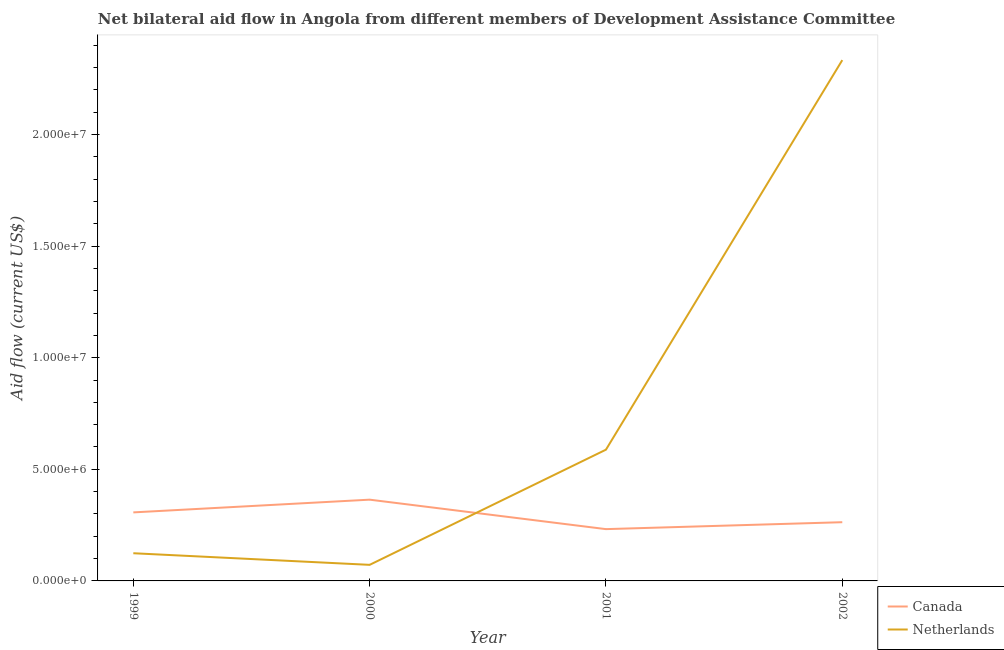How many different coloured lines are there?
Keep it short and to the point. 2. Does the line corresponding to amount of aid given by canada intersect with the line corresponding to amount of aid given by netherlands?
Make the answer very short. Yes. What is the amount of aid given by netherlands in 2000?
Provide a short and direct response. 7.20e+05. Across all years, what is the maximum amount of aid given by netherlands?
Offer a terse response. 2.33e+07. Across all years, what is the minimum amount of aid given by canada?
Provide a short and direct response. 2.32e+06. In which year was the amount of aid given by netherlands minimum?
Ensure brevity in your answer.  2000. What is the total amount of aid given by canada in the graph?
Your answer should be compact. 1.17e+07. What is the difference between the amount of aid given by netherlands in 1999 and that in 2002?
Keep it short and to the point. -2.21e+07. What is the difference between the amount of aid given by netherlands in 2002 and the amount of aid given by canada in 2001?
Keep it short and to the point. 2.10e+07. What is the average amount of aid given by canada per year?
Your response must be concise. 2.92e+06. In the year 2001, what is the difference between the amount of aid given by netherlands and amount of aid given by canada?
Give a very brief answer. 3.56e+06. In how many years, is the amount of aid given by netherlands greater than 5000000 US$?
Offer a very short reply. 2. What is the ratio of the amount of aid given by canada in 2000 to that in 2002?
Make the answer very short. 1.38. Is the difference between the amount of aid given by netherlands in 1999 and 2000 greater than the difference between the amount of aid given by canada in 1999 and 2000?
Your answer should be very brief. Yes. What is the difference between the highest and the second highest amount of aid given by netherlands?
Provide a short and direct response. 1.74e+07. What is the difference between the highest and the lowest amount of aid given by netherlands?
Your answer should be very brief. 2.26e+07. In how many years, is the amount of aid given by netherlands greater than the average amount of aid given by netherlands taken over all years?
Your answer should be very brief. 1. Is the sum of the amount of aid given by netherlands in 2000 and 2002 greater than the maximum amount of aid given by canada across all years?
Offer a terse response. Yes. Is the amount of aid given by canada strictly greater than the amount of aid given by netherlands over the years?
Provide a short and direct response. No. Is the amount of aid given by netherlands strictly less than the amount of aid given by canada over the years?
Your answer should be very brief. No. How many years are there in the graph?
Keep it short and to the point. 4. Are the values on the major ticks of Y-axis written in scientific E-notation?
Make the answer very short. Yes. Does the graph contain any zero values?
Your answer should be very brief. No. Does the graph contain grids?
Your answer should be compact. No. Where does the legend appear in the graph?
Provide a succinct answer. Bottom right. How are the legend labels stacked?
Keep it short and to the point. Vertical. What is the title of the graph?
Make the answer very short. Net bilateral aid flow in Angola from different members of Development Assistance Committee. Does "ODA received" appear as one of the legend labels in the graph?
Provide a short and direct response. No. What is the label or title of the X-axis?
Provide a succinct answer. Year. What is the label or title of the Y-axis?
Offer a very short reply. Aid flow (current US$). What is the Aid flow (current US$) in Canada in 1999?
Provide a short and direct response. 3.07e+06. What is the Aid flow (current US$) of Netherlands in 1999?
Offer a terse response. 1.24e+06. What is the Aid flow (current US$) in Canada in 2000?
Provide a short and direct response. 3.64e+06. What is the Aid flow (current US$) in Netherlands in 2000?
Your answer should be very brief. 7.20e+05. What is the Aid flow (current US$) in Canada in 2001?
Give a very brief answer. 2.32e+06. What is the Aid flow (current US$) of Netherlands in 2001?
Provide a short and direct response. 5.88e+06. What is the Aid flow (current US$) in Canada in 2002?
Your answer should be compact. 2.63e+06. What is the Aid flow (current US$) in Netherlands in 2002?
Offer a terse response. 2.33e+07. Across all years, what is the maximum Aid flow (current US$) of Canada?
Give a very brief answer. 3.64e+06. Across all years, what is the maximum Aid flow (current US$) in Netherlands?
Give a very brief answer. 2.33e+07. Across all years, what is the minimum Aid flow (current US$) of Canada?
Provide a short and direct response. 2.32e+06. Across all years, what is the minimum Aid flow (current US$) of Netherlands?
Offer a terse response. 7.20e+05. What is the total Aid flow (current US$) of Canada in the graph?
Offer a terse response. 1.17e+07. What is the total Aid flow (current US$) of Netherlands in the graph?
Your answer should be very brief. 3.12e+07. What is the difference between the Aid flow (current US$) of Canada in 1999 and that in 2000?
Provide a succinct answer. -5.70e+05. What is the difference between the Aid flow (current US$) in Netherlands in 1999 and that in 2000?
Your response must be concise. 5.20e+05. What is the difference between the Aid flow (current US$) in Canada in 1999 and that in 2001?
Your answer should be very brief. 7.50e+05. What is the difference between the Aid flow (current US$) in Netherlands in 1999 and that in 2001?
Keep it short and to the point. -4.64e+06. What is the difference between the Aid flow (current US$) of Netherlands in 1999 and that in 2002?
Give a very brief answer. -2.21e+07. What is the difference between the Aid flow (current US$) of Canada in 2000 and that in 2001?
Ensure brevity in your answer.  1.32e+06. What is the difference between the Aid flow (current US$) in Netherlands in 2000 and that in 2001?
Your answer should be very brief. -5.16e+06. What is the difference between the Aid flow (current US$) of Canada in 2000 and that in 2002?
Your answer should be compact. 1.01e+06. What is the difference between the Aid flow (current US$) of Netherlands in 2000 and that in 2002?
Your answer should be compact. -2.26e+07. What is the difference between the Aid flow (current US$) of Canada in 2001 and that in 2002?
Keep it short and to the point. -3.10e+05. What is the difference between the Aid flow (current US$) in Netherlands in 2001 and that in 2002?
Offer a very short reply. -1.74e+07. What is the difference between the Aid flow (current US$) in Canada in 1999 and the Aid flow (current US$) in Netherlands in 2000?
Your answer should be very brief. 2.35e+06. What is the difference between the Aid flow (current US$) of Canada in 1999 and the Aid flow (current US$) of Netherlands in 2001?
Keep it short and to the point. -2.81e+06. What is the difference between the Aid flow (current US$) in Canada in 1999 and the Aid flow (current US$) in Netherlands in 2002?
Offer a terse response. -2.03e+07. What is the difference between the Aid flow (current US$) in Canada in 2000 and the Aid flow (current US$) in Netherlands in 2001?
Make the answer very short. -2.24e+06. What is the difference between the Aid flow (current US$) of Canada in 2000 and the Aid flow (current US$) of Netherlands in 2002?
Offer a terse response. -1.97e+07. What is the difference between the Aid flow (current US$) of Canada in 2001 and the Aid flow (current US$) of Netherlands in 2002?
Your answer should be compact. -2.10e+07. What is the average Aid flow (current US$) in Canada per year?
Keep it short and to the point. 2.92e+06. What is the average Aid flow (current US$) of Netherlands per year?
Your response must be concise. 7.79e+06. In the year 1999, what is the difference between the Aid flow (current US$) of Canada and Aid flow (current US$) of Netherlands?
Provide a succinct answer. 1.83e+06. In the year 2000, what is the difference between the Aid flow (current US$) in Canada and Aid flow (current US$) in Netherlands?
Offer a very short reply. 2.92e+06. In the year 2001, what is the difference between the Aid flow (current US$) in Canada and Aid flow (current US$) in Netherlands?
Your response must be concise. -3.56e+06. In the year 2002, what is the difference between the Aid flow (current US$) in Canada and Aid flow (current US$) in Netherlands?
Provide a short and direct response. -2.07e+07. What is the ratio of the Aid flow (current US$) in Canada in 1999 to that in 2000?
Your answer should be very brief. 0.84. What is the ratio of the Aid flow (current US$) of Netherlands in 1999 to that in 2000?
Ensure brevity in your answer.  1.72. What is the ratio of the Aid flow (current US$) in Canada in 1999 to that in 2001?
Offer a very short reply. 1.32. What is the ratio of the Aid flow (current US$) in Netherlands in 1999 to that in 2001?
Give a very brief answer. 0.21. What is the ratio of the Aid flow (current US$) in Canada in 1999 to that in 2002?
Keep it short and to the point. 1.17. What is the ratio of the Aid flow (current US$) of Netherlands in 1999 to that in 2002?
Your answer should be very brief. 0.05. What is the ratio of the Aid flow (current US$) in Canada in 2000 to that in 2001?
Keep it short and to the point. 1.57. What is the ratio of the Aid flow (current US$) in Netherlands in 2000 to that in 2001?
Ensure brevity in your answer.  0.12. What is the ratio of the Aid flow (current US$) in Canada in 2000 to that in 2002?
Your answer should be very brief. 1.38. What is the ratio of the Aid flow (current US$) of Netherlands in 2000 to that in 2002?
Provide a succinct answer. 0.03. What is the ratio of the Aid flow (current US$) of Canada in 2001 to that in 2002?
Your answer should be very brief. 0.88. What is the ratio of the Aid flow (current US$) of Netherlands in 2001 to that in 2002?
Provide a succinct answer. 0.25. What is the difference between the highest and the second highest Aid flow (current US$) of Canada?
Provide a short and direct response. 5.70e+05. What is the difference between the highest and the second highest Aid flow (current US$) in Netherlands?
Offer a terse response. 1.74e+07. What is the difference between the highest and the lowest Aid flow (current US$) in Canada?
Ensure brevity in your answer.  1.32e+06. What is the difference between the highest and the lowest Aid flow (current US$) in Netherlands?
Provide a short and direct response. 2.26e+07. 